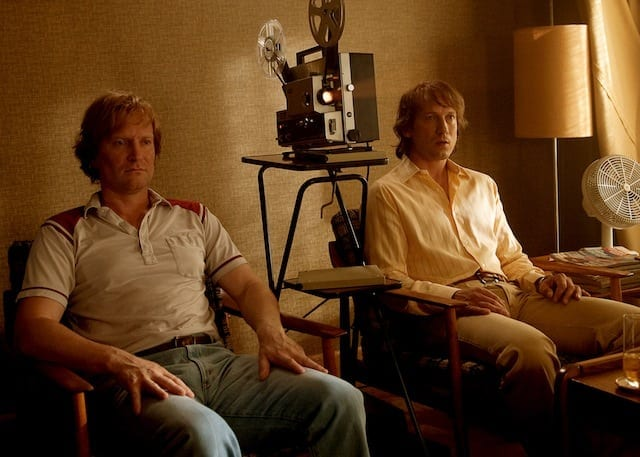What might be the professional relationship between these two individuals? These two individuals might share a professional relationship likely tied to the film industry. Given their relaxed yet attentive demeanor and the presence of a film projector and other cinematic elements in the room, they could be colleagues possibly engaging in a film editing session, critique, or a planning discussion for a movie project. 